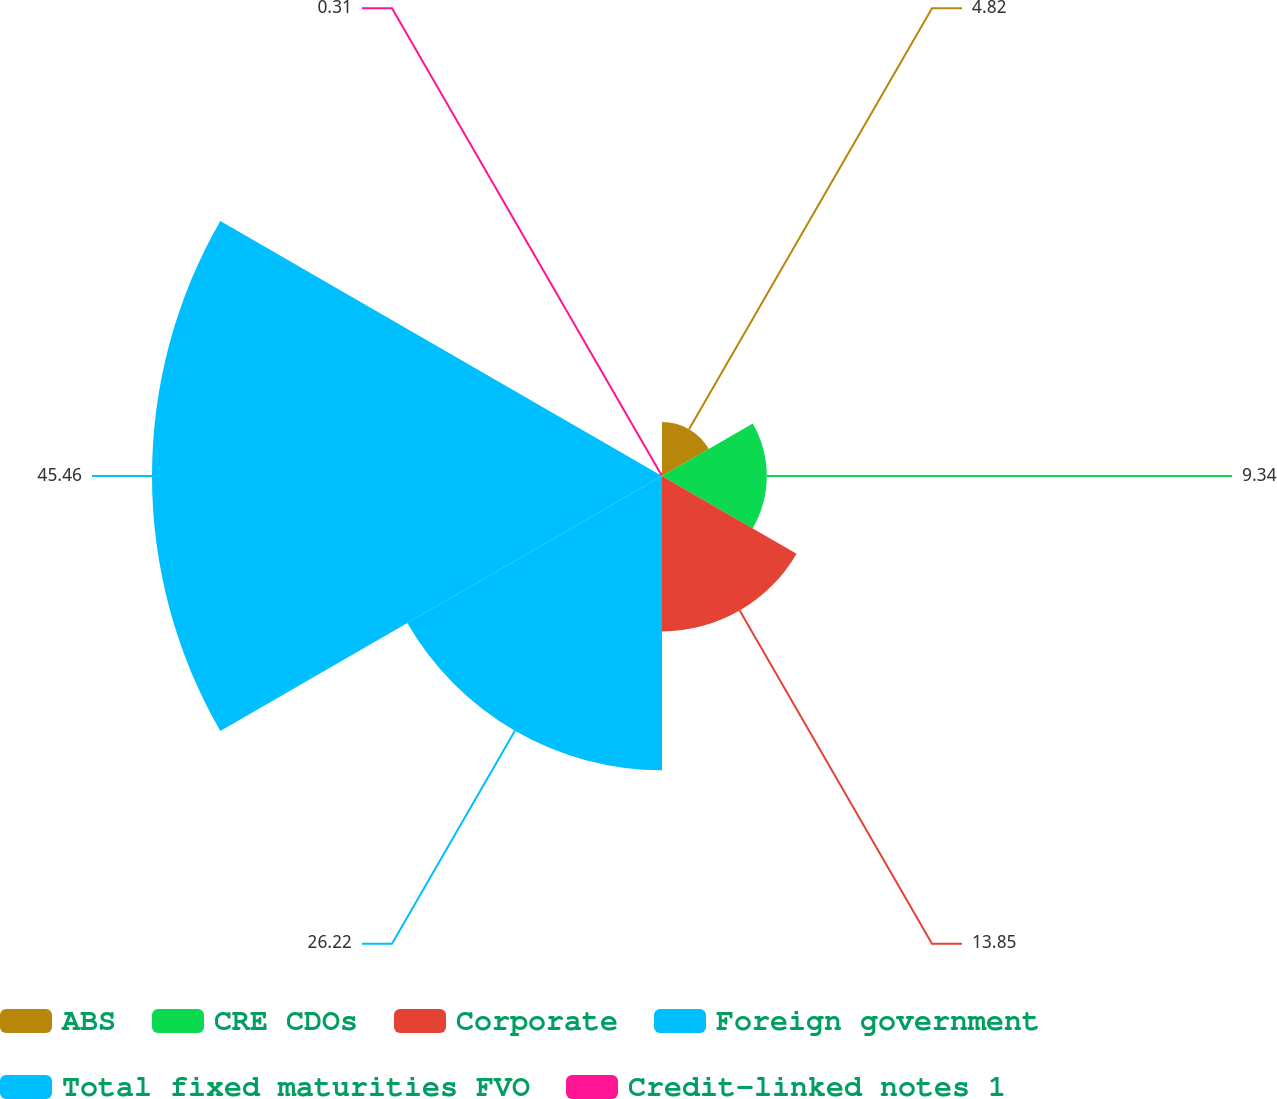Convert chart to OTSL. <chart><loc_0><loc_0><loc_500><loc_500><pie_chart><fcel>ABS<fcel>CRE CDOs<fcel>Corporate<fcel>Foreign government<fcel>Total fixed maturities FVO<fcel>Credit-linked notes 1<nl><fcel>4.82%<fcel>9.34%<fcel>13.85%<fcel>26.22%<fcel>45.46%<fcel>0.31%<nl></chart> 